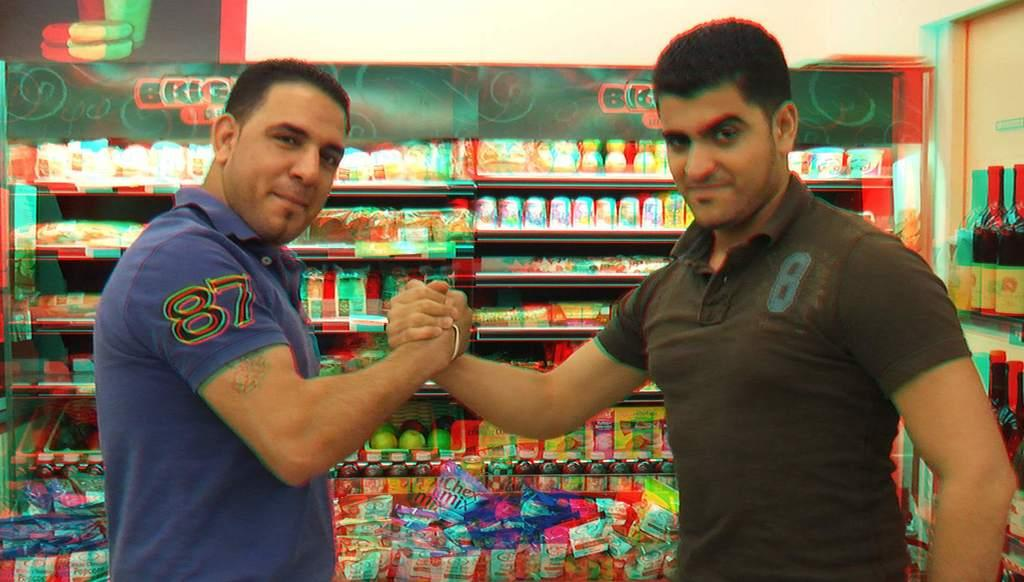<image>
Share a concise interpretation of the image provided. Two men are clasping their hands together in front of a grocery display that includes Chex Mix. 